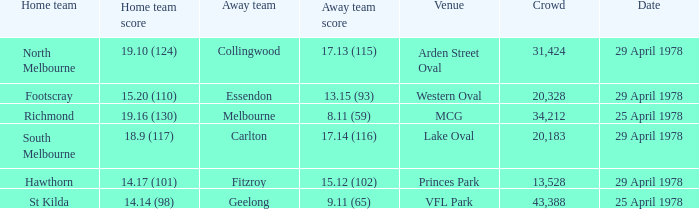What was the away team that played at Princes Park? Fitzroy. 